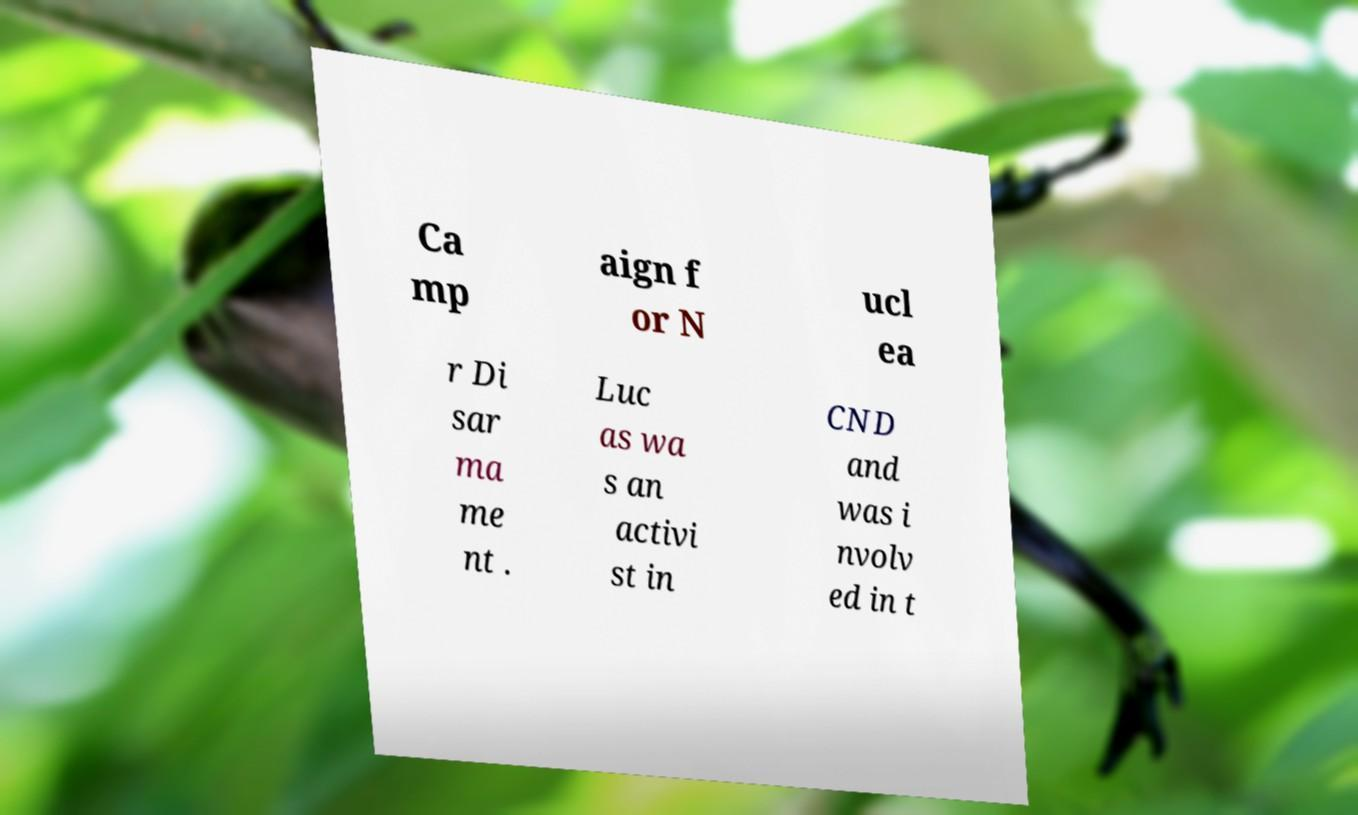I need the written content from this picture converted into text. Can you do that? Ca mp aign f or N ucl ea r Di sar ma me nt . Luc as wa s an activi st in CND and was i nvolv ed in t 